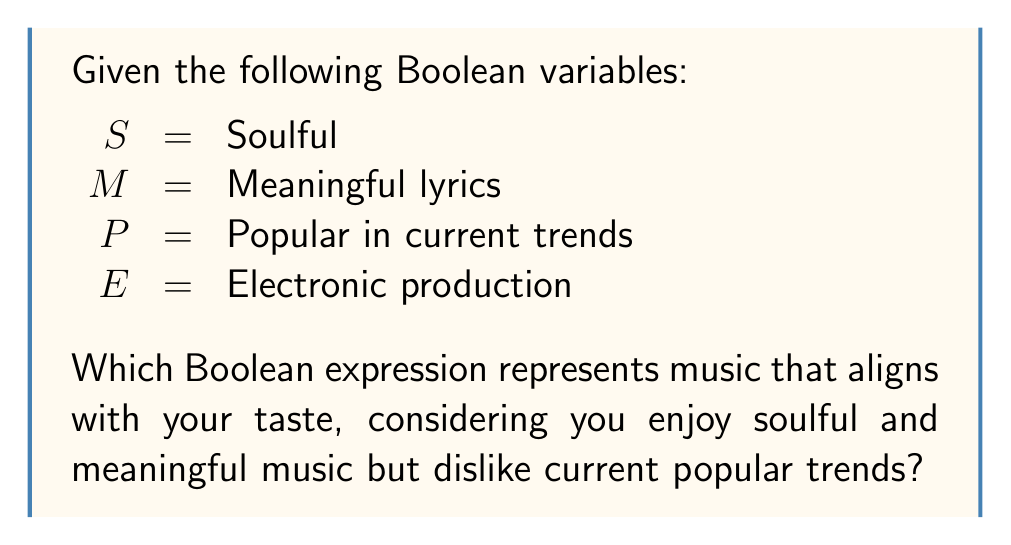Could you help me with this problem? Let's approach this step-by-step:

1. We know you enjoy soulful music, so $S$ should be true (1).
2. You also appreciate meaningful lyrics, so $M$ should be true (1).
3. You dislike current popular trends, so $P$ should be false (0).
4. Electronic production isn't explicitly mentioned in your preferences, so we can consider it optional.

To construct the Boolean expression:

1. For soulful and meaningful music: $S \land M$
2. To exclude popular trends: $\lnot P$
3. Combining these: $(S \land M) \land \lnot P$

We don't need to include $E$ in our expression as it's not a determining factor for your taste.

The final Boolean expression is:

$$(S \land M) \land \lnot P$$

This expression will be true (1) for music that is both soulful and meaningful, but not currently popular, which aligns with your described taste.
Answer: $(S \land M) \land \lnot P$ 